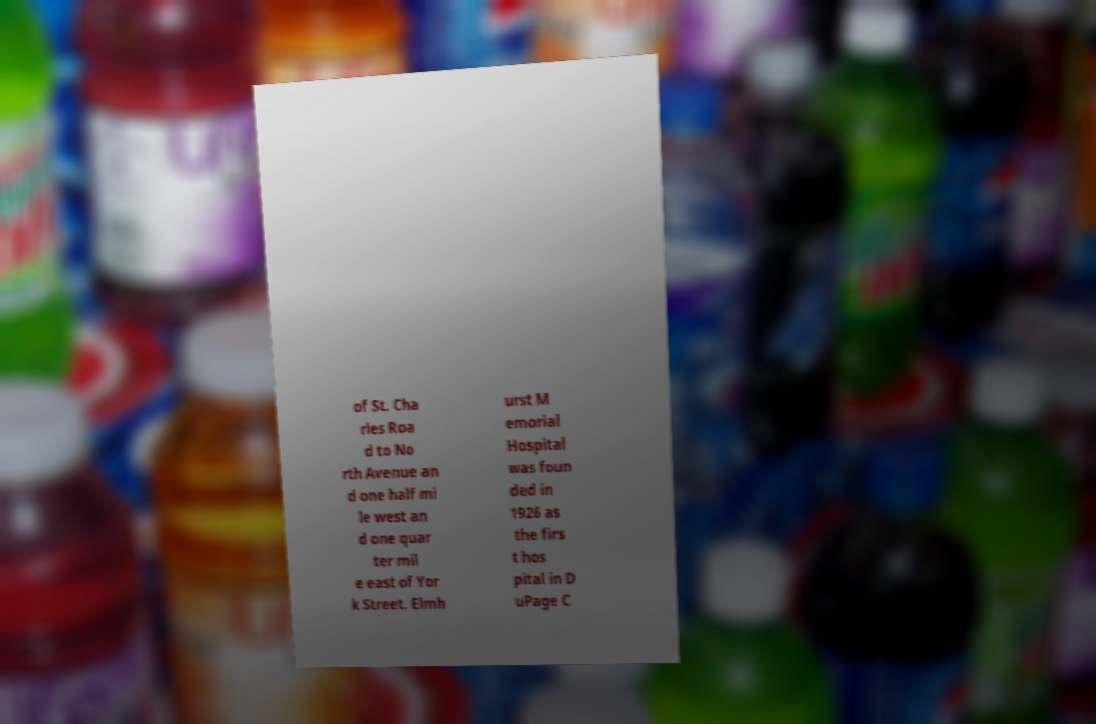For documentation purposes, I need the text within this image transcribed. Could you provide that? of St. Cha rles Roa d to No rth Avenue an d one half mi le west an d one quar ter mil e east of Yor k Street. Elmh urst M emorial Hospital was foun ded in 1926 as the firs t hos pital in D uPage C 